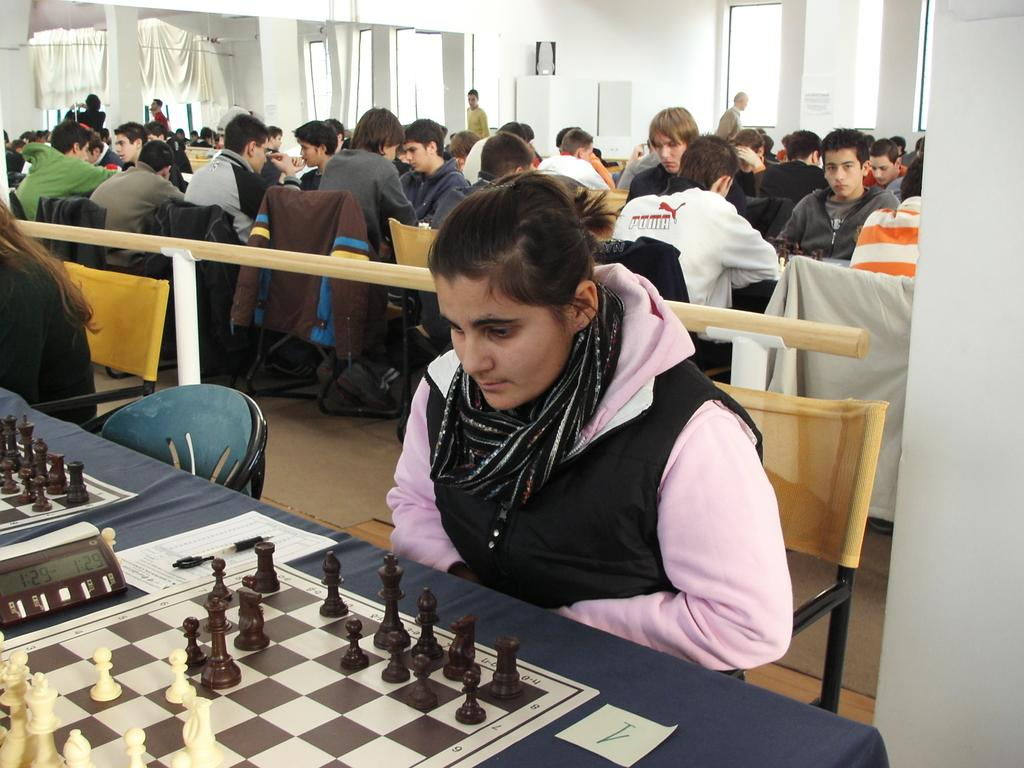What is the color of the wall in the image? The wall in the image is white. What can be seen hanging near the wall? There is a curtain in the image. What are the people in the image doing? The people are sitting on chairs in the image. What is on the table in the image? There is a chess board, coins, and papers on the table in the image. What type of rat can be seen interacting with the chess board in the image? There is no rat present in the image; it features people sitting on chairs and a table with a chess board and other objects. What type of voice can be heard coming from the cemetery in the image? There is no cemetery present in the image, and therefore no sounds or voices can be heard from it. 